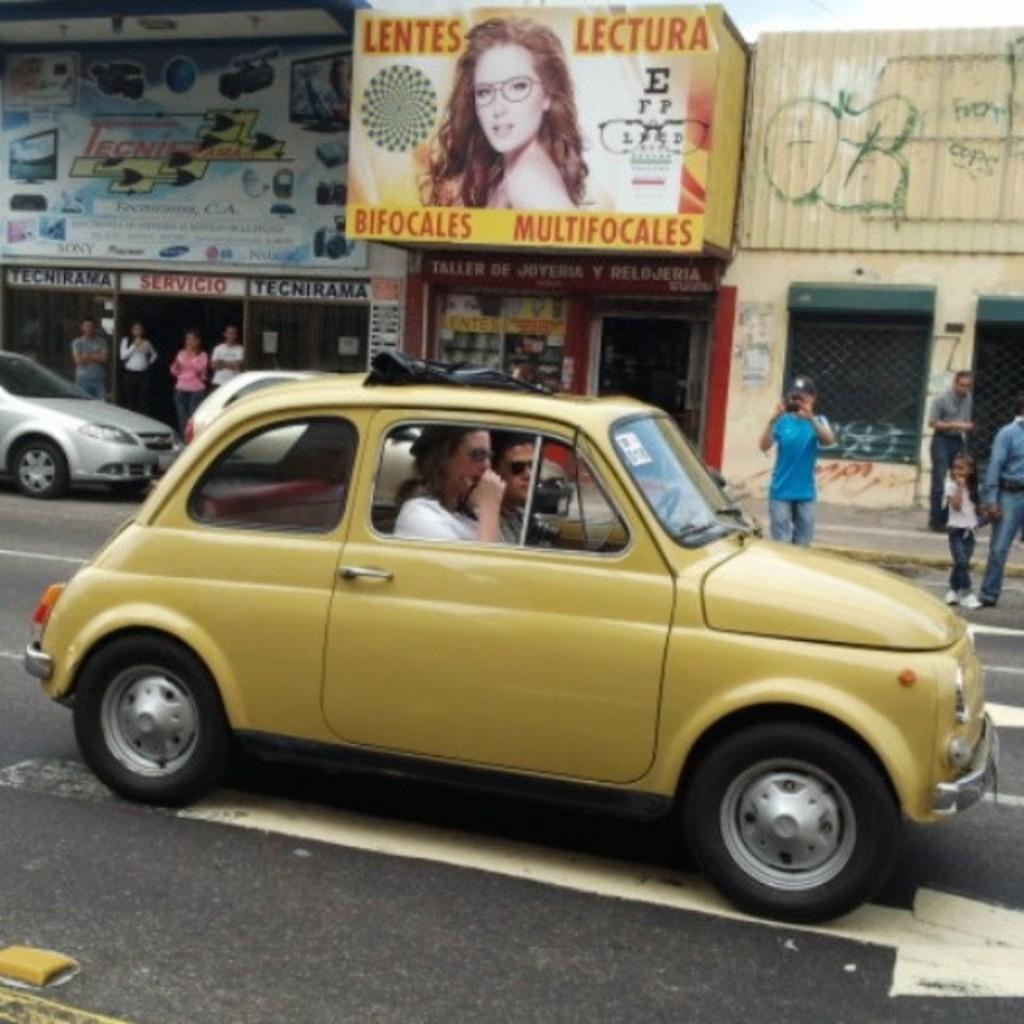Please provide a concise description of this image. There is a car on road which was driven by man and woman on the other side there is a poster of woman showing and at the corner there are few other cars standing. 